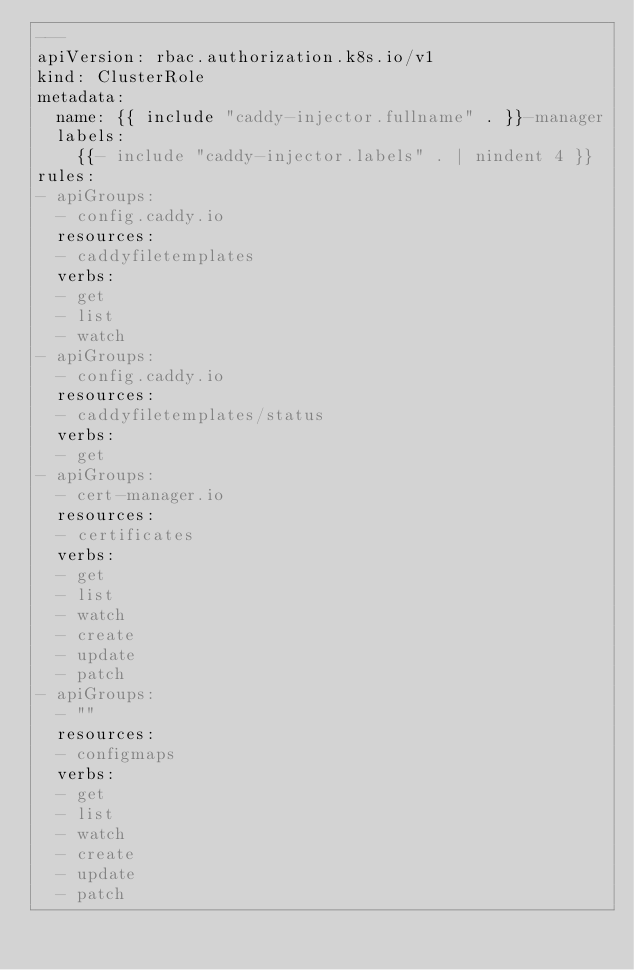<code> <loc_0><loc_0><loc_500><loc_500><_YAML_>---
apiVersion: rbac.authorization.k8s.io/v1
kind: ClusterRole
metadata:
  name: {{ include "caddy-injector.fullname" . }}-manager
  labels:
    {{- include "caddy-injector.labels" . | nindent 4 }}
rules:
- apiGroups:
  - config.caddy.io
  resources:
  - caddyfiletemplates
  verbs:
  - get
  - list
  - watch
- apiGroups:
  - config.caddy.io
  resources:
  - caddyfiletemplates/status
  verbs:
  - get
- apiGroups:
  - cert-manager.io
  resources:
  - certificates
  verbs:
  - get
  - list
  - watch
  - create
  - update
  - patch
- apiGroups:
  - ""
  resources:
  - configmaps
  verbs:
  - get
  - list
  - watch
  - create
  - update
  - patch</code> 